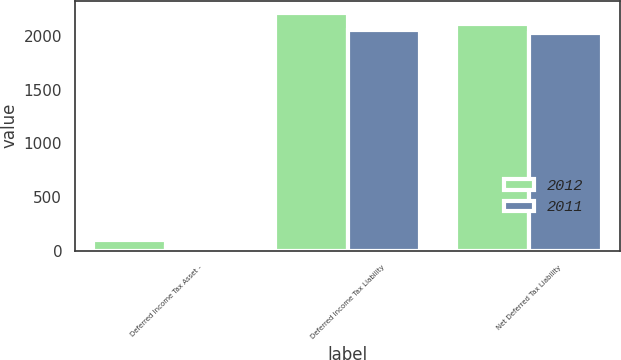<chart> <loc_0><loc_0><loc_500><loc_500><stacked_bar_chart><ecel><fcel>Deferred Income Tax Asset -<fcel>Deferred Income Tax Liability<fcel>Net Deferred Tax Liability<nl><fcel>2012<fcel>106<fcel>2218<fcel>2112<nl><fcel>2011<fcel>41<fcel>2059<fcel>2024<nl></chart> 